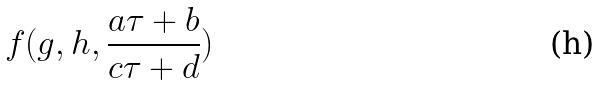<formula> <loc_0><loc_0><loc_500><loc_500>f ( g , h , \frac { a \tau + b } { c \tau + d } )</formula> 